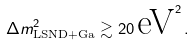<formula> <loc_0><loc_0><loc_500><loc_500>\Delta { m } ^ { 2 } _ { \text {LSND} + \text {Ga} } \gtrsim 2 0 \, \text {eV} ^ { 2 } \, .</formula> 